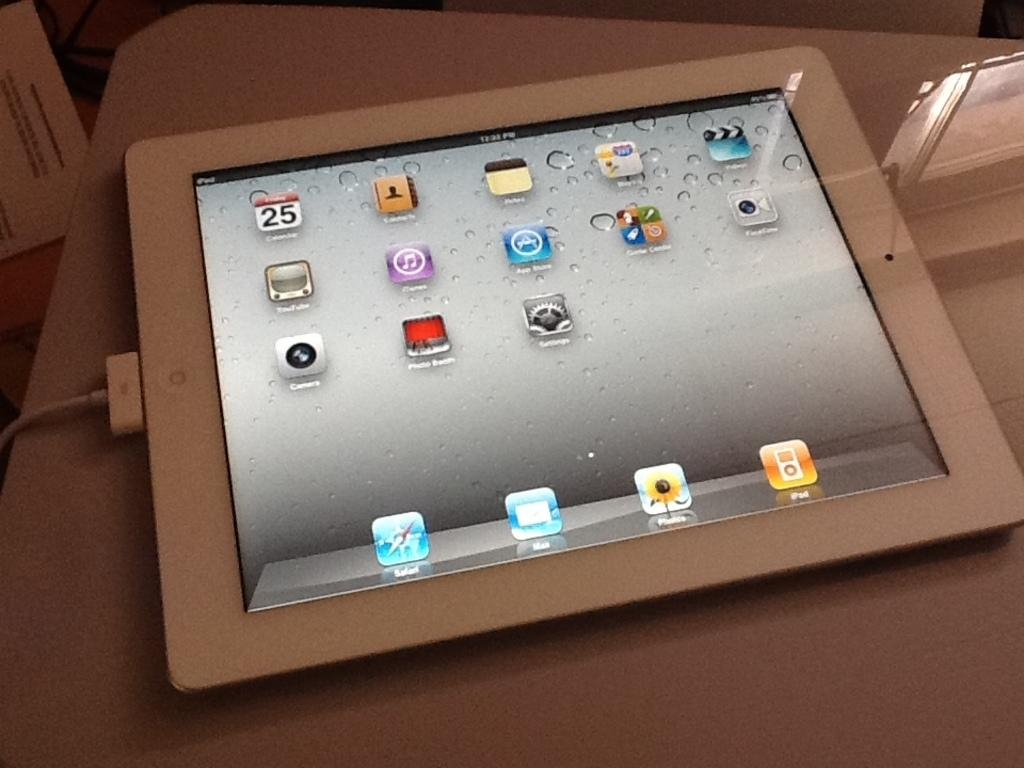What device is shown with a display in the image? There is a tablet with a display in the image. What can be seen on the display of the tablet? There are apps visible on the display. How is the tablet being powered in the image? There is a charging cable connected to the tablet. Where might the tablet be placed in the image? The tablet is likely placed on a table. How many cherries are on the display of the tablet? There are no cherries visible on the display of the tablet; only apps are present. Is the person using the tablet shown sleeping in the image? There is no person visible in the image, so it cannot be determined if anyone is sleeping. 